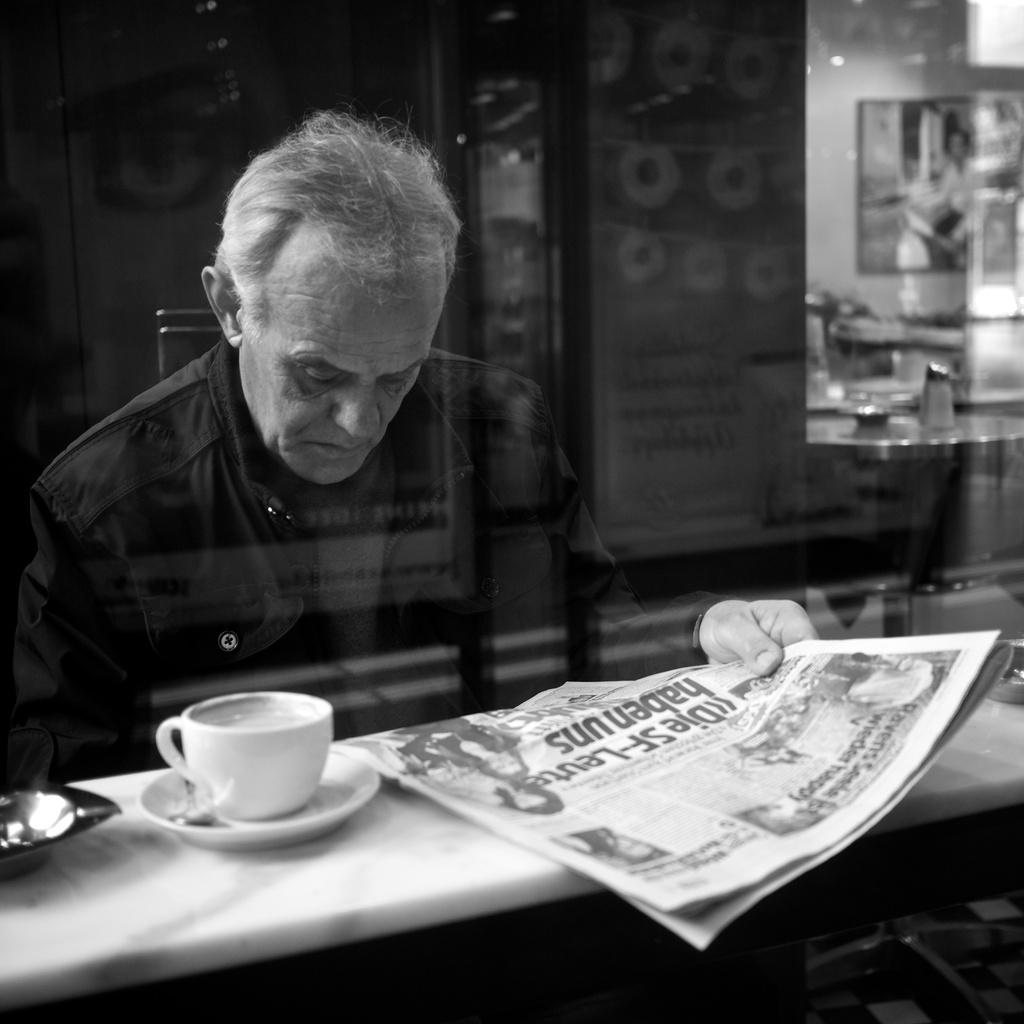What is the person in the image doing? The person is holding a newspaper in the image. What is the person wearing? The person is wearing a black dress. Where is the newspaper placed? The newspaper is placed on a table. What else can be seen on the table? There is a cup beside the newspaper on the table. Can you see any salt being sprinkled on the newspaper in the image? There is no salt present in the image, nor is it being sprinkled on the newspaper. 